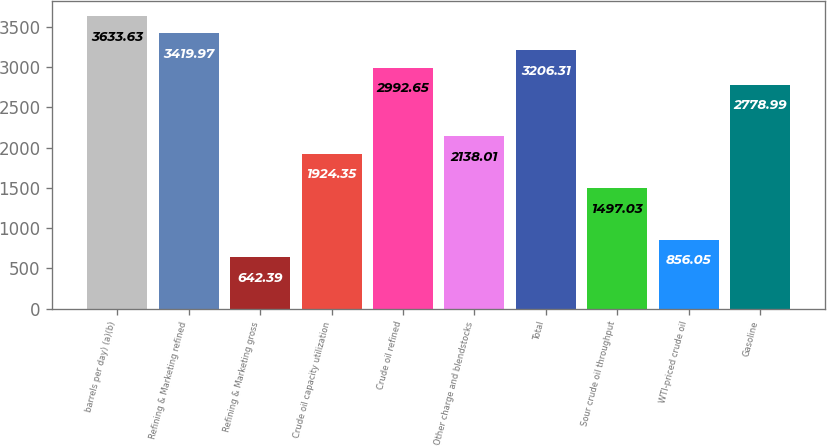Convert chart to OTSL. <chart><loc_0><loc_0><loc_500><loc_500><bar_chart><fcel>barrels per day) (a)(b)<fcel>Refining & Marketing refined<fcel>Refining & Marketing gross<fcel>Crude oil capacity utilization<fcel>Crude oil refined<fcel>Other charge and blendstocks<fcel>Total<fcel>Sour crude oil throughput<fcel>WTI-priced crude oil<fcel>Gasoline<nl><fcel>3633.63<fcel>3419.97<fcel>642.39<fcel>1924.35<fcel>2992.65<fcel>2138.01<fcel>3206.31<fcel>1497.03<fcel>856.05<fcel>2778.99<nl></chart> 